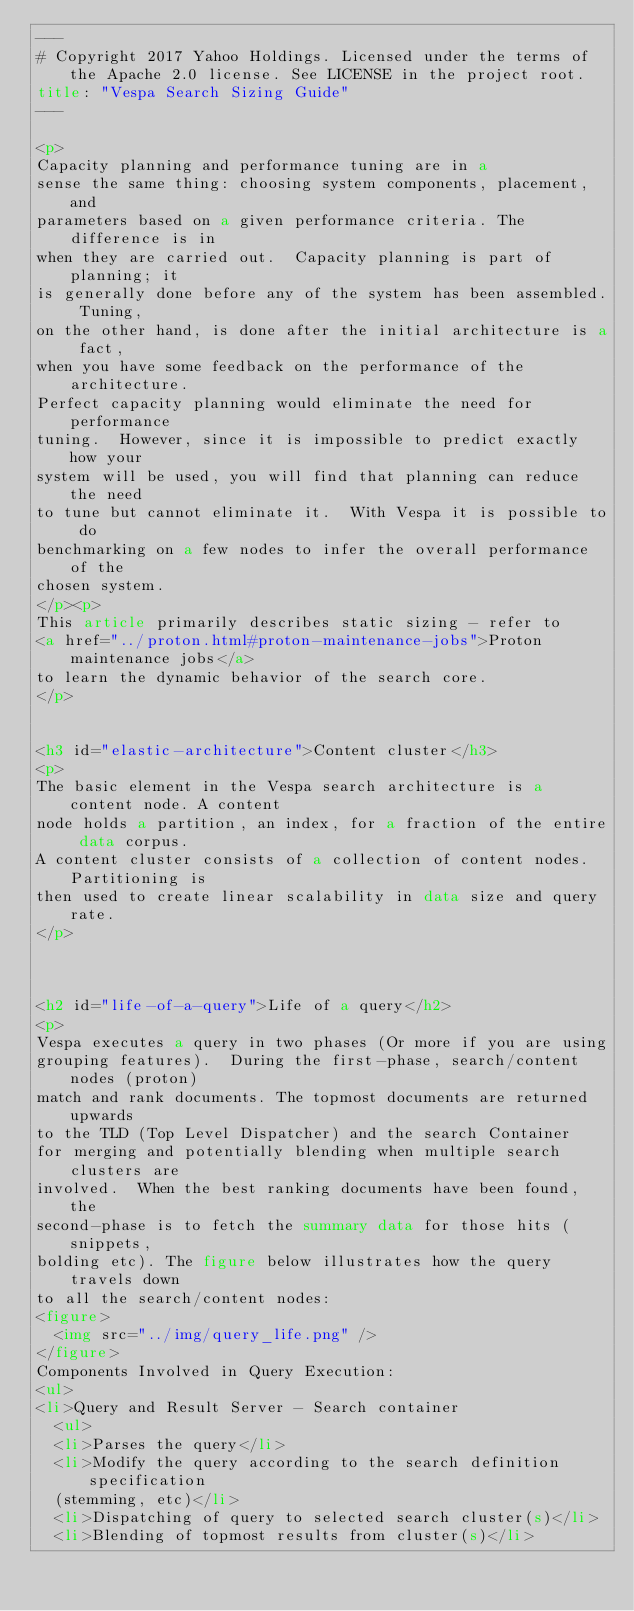<code> <loc_0><loc_0><loc_500><loc_500><_HTML_>---
# Copyright 2017 Yahoo Holdings. Licensed under the terms of the Apache 2.0 license. See LICENSE in the project root.
title: "Vespa Search Sizing Guide"
---

<p>
Capacity planning and performance tuning are in a
sense the same thing: choosing system components, placement, and
parameters based on a given performance criteria. The difference is in
when they are carried out.  Capacity planning is part of planning; it
is generally done before any of the system has been assembled. Tuning,
on the other hand, is done after the initial architecture is a fact,
when you have some feedback on the performance of the architecture.
Perfect capacity planning would eliminate the need for performance
tuning.  However, since it is impossible to predict exactly how your
system will be used, you will find that planning can reduce the need
to tune but cannot eliminate it.  With Vespa it is possible to do
benchmarking on a few nodes to infer the overall performance of the
chosen system.
</p><p>
This article primarily describes static sizing - refer to
<a href="../proton.html#proton-maintenance-jobs">Proton maintenance jobs</a>
to learn the dynamic behavior of the search core.
</p>


<h3 id="elastic-architecture">Content cluster</h3>
<p>
The basic element in the Vespa search architecture is a content node. A content
node holds a partition, an index, for a fraction of the entire data corpus.
A content cluster consists of a collection of content nodes.  Partitioning is
then used to create linear scalability in data size and query rate.
</p>



<h2 id="life-of-a-query">Life of a query</h2>
<p>
Vespa executes a query in two phases (Or more if you are using
grouping features).  During the first-phase, search/content nodes (proton)
match and rank documents. The topmost documents are returned upwards
to the TLD (Top Level Dispatcher) and the search Container 
for merging and potentially blending when multiple search clusters are
involved.  When the best ranking documents have been found, the
second-phase is to fetch the summary data for those hits (snippets,
bolding etc). The figure below illustrates how the query travels down
to all the search/content nodes:
<figure>
  <img src="../img/query_life.png" />
</figure>
Components Involved in Query Execution:
<ul>
<li>Query and Result Server - Search container
  <ul>
  <li>Parses the query</li>
  <li>Modify the query according to the search definition specification
  (stemming, etc)</li>
  <li>Dispatching of query to selected search cluster(s)</li>
  <li>Blending of topmost results from cluster(s)</li></code> 